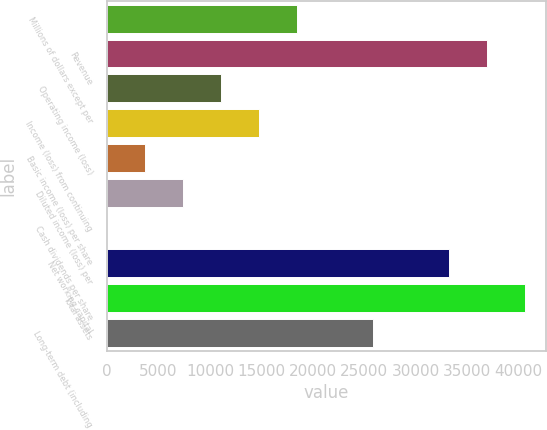Convert chart. <chart><loc_0><loc_0><loc_500><loc_500><bar_chart><fcel>Millions of dollars except per<fcel>Revenue<fcel>Operating income (loss)<fcel>Income (loss) from continuing<fcel>Basic income (loss) per share<fcel>Diluted income (loss) per<fcel>Cash dividends per share<fcel>Net working capital<fcel>Total assets<fcel>Long-term debt (including<nl><fcel>18471.4<fcel>36942<fcel>11083.1<fcel>14777.2<fcel>3694.85<fcel>7388.98<fcel>0.72<fcel>33247.9<fcel>40636.2<fcel>25859.6<nl></chart> 